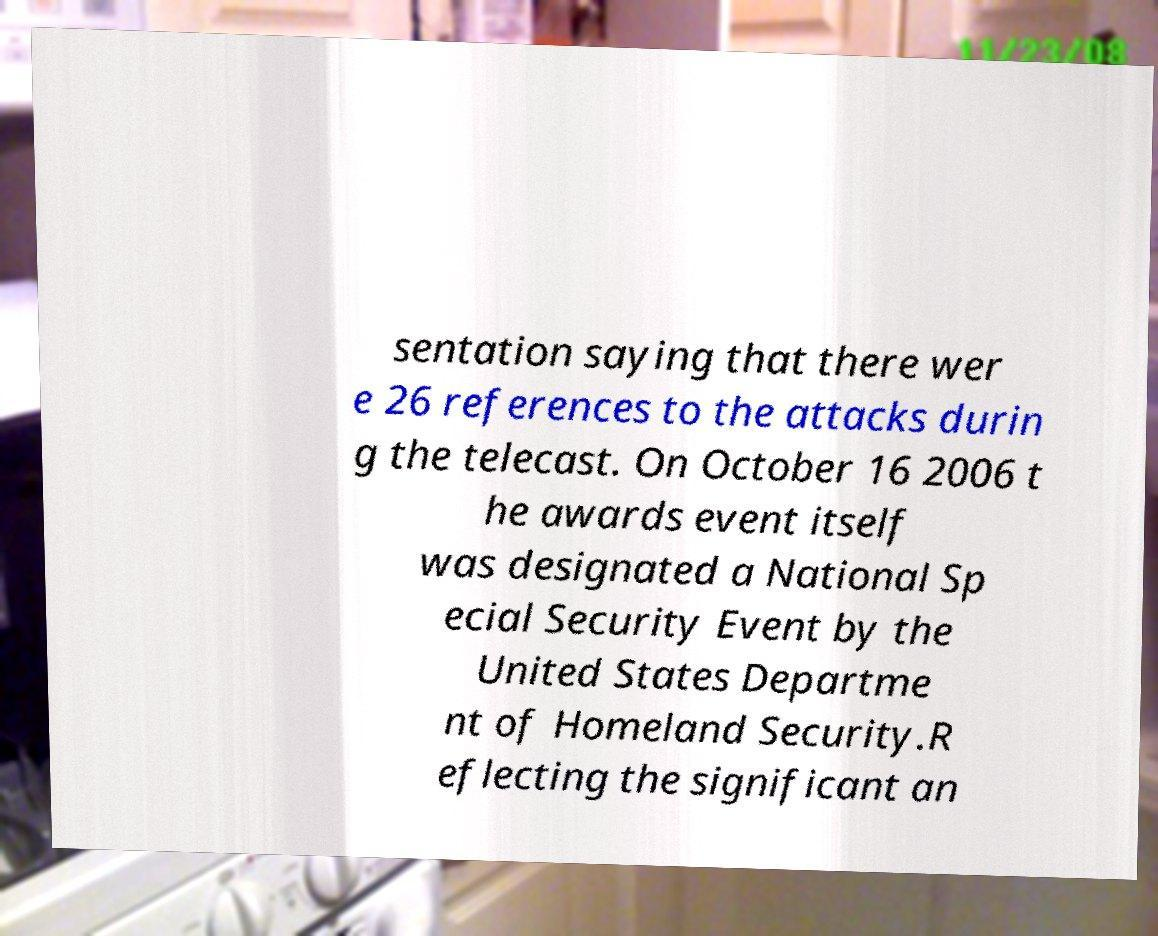Please identify and transcribe the text found in this image. sentation saying that there wer e 26 references to the attacks durin g the telecast. On October 16 2006 t he awards event itself was designated a National Sp ecial Security Event by the United States Departme nt of Homeland Security.R eflecting the significant an 